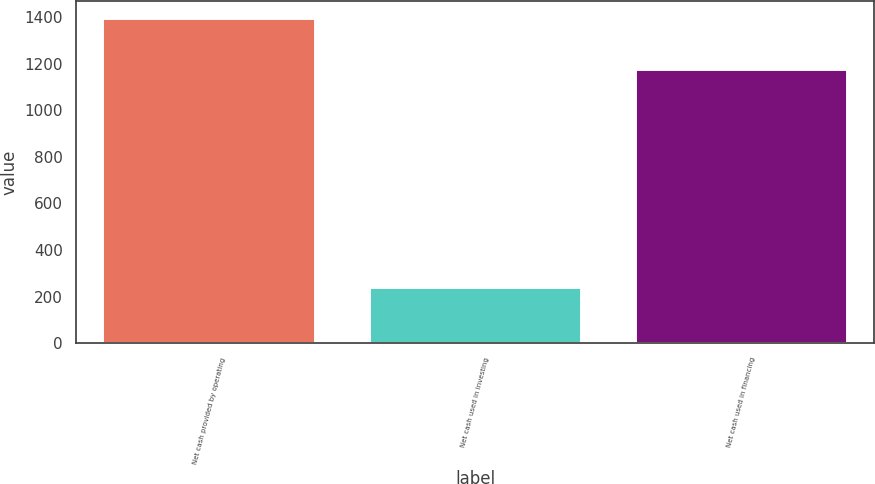<chart> <loc_0><loc_0><loc_500><loc_500><bar_chart><fcel>Net cash provided by operating<fcel>Net cash used in investing<fcel>Net cash used in financing<nl><fcel>1396.5<fcel>242.5<fcel>1174.7<nl></chart> 